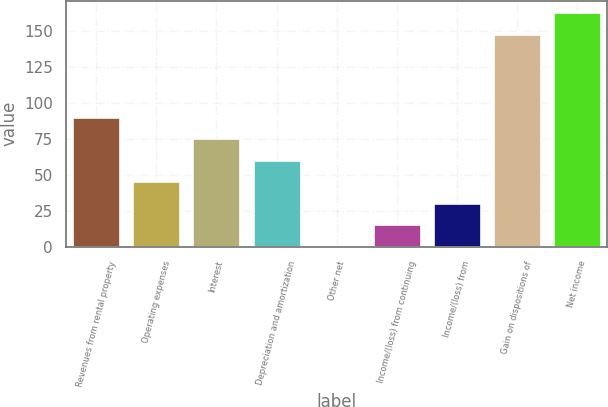Convert chart. <chart><loc_0><loc_0><loc_500><loc_500><bar_chart><fcel>Revenues from rental property<fcel>Operating expenses<fcel>Interest<fcel>Depreciation and amortization<fcel>Other net<fcel>Income/(loss) from continuing<fcel>Income/(loss) from<fcel>Gain on dispositions of<fcel>Net income<nl><fcel>90.34<fcel>45.52<fcel>75.4<fcel>60.46<fcel>0.7<fcel>15.64<fcel>30.58<fcel>147.8<fcel>162.74<nl></chart> 